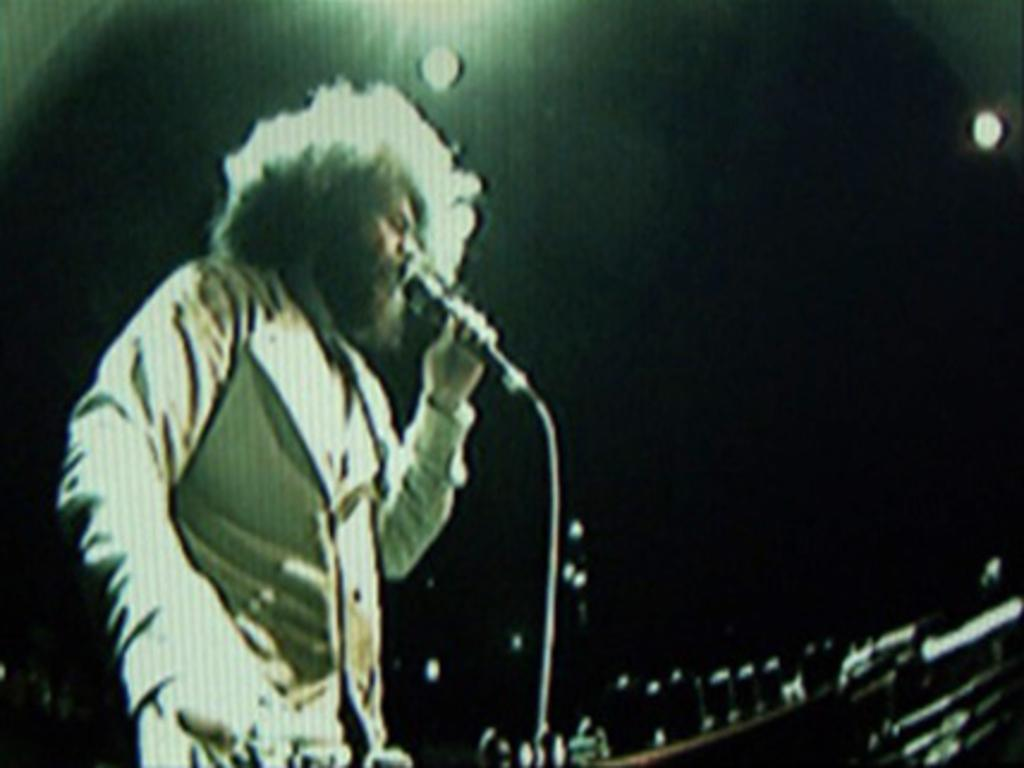Who is present in the image? There is a man in the image. What is the man doing in the image? The man is standing and holding a mic in his hand. What can be observed about the background of the image? The background of the image is dark. What else can be seen in the image besides the man? There are lights visible in the image. Where is the bomb located in the image? There is no bomb present in the image. What type of stove can be seen in the image? There is no stove present in the image. 